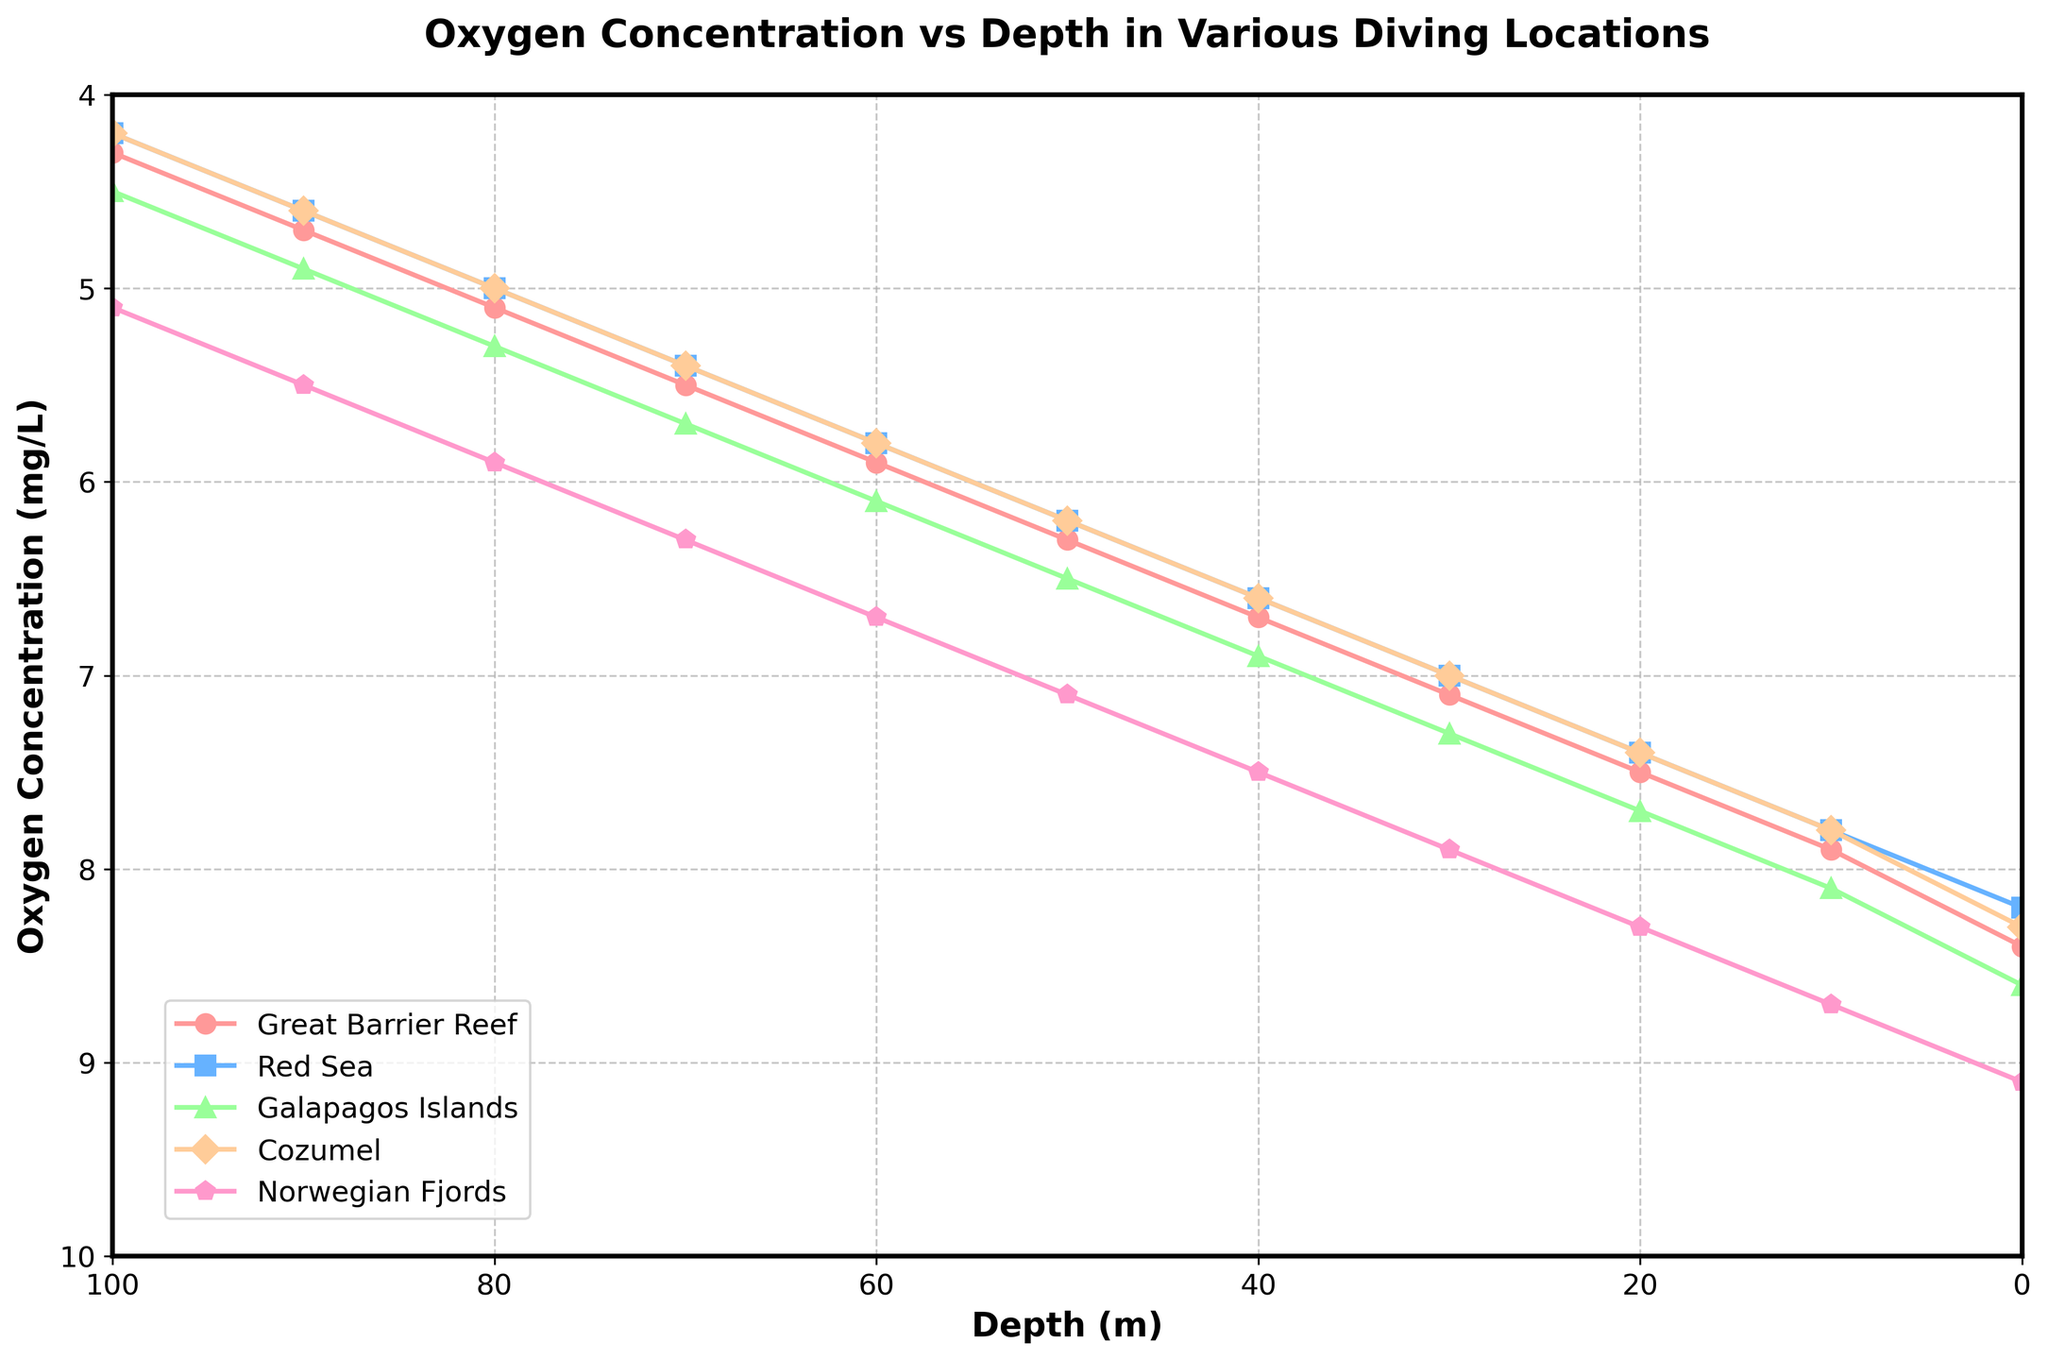Which location has the highest oxygen concentration at the surface (0 m)? Observe the y-axis values at 0 m depth for each location. The highest value is for the Norwegian Fjords.
Answer: Norwegian Fjords How does oxygen concentration in the Red Sea at 50 m depth compare to that in the Galapagos Islands at the same depth? Check the y-axis values at 50 m depth for both locations. The Red Sea has 6.2 mg/L and the Galapagos Islands have 6.5 mg/L.
Answer: Galapagos Islands is higher What is the average oxygen concentration at 30 m depth across all locations? Sum the oxygen concentrations at 30 m for all locations (7.1 + 7.0 + 7.3 + 7.0 + 7.9) and divide by the number of locations (5). Calculation: (7.1 + 7.0 + 7.3 + 7.0 + 7.9) / 5 = 36.3 / 5 = 7.26 mg/L.
Answer: 7.26 mg/L At what depth does the Great Barrier Reef's oxygen concentration first drop below 5 mg/L? Check the plot for the Great Barrier Reef line, finding where it first dips below 5 mg/L. The depth is at 80 m.
Answer: 80 m Which location consistently has the lowest oxygen concentration across all depths? Compare the lines for the lowest position at each depth increment. The Red Sea consistently appears lower than others.
Answer: Red Sea Which depth range experiences the steepest decline in oxygen concentration in Cozumel? Check the slope of the Cozumel line across different depth ranges. The steepest decline appears between 0 m and 10 m.
Answer: 0 m to 10 m What is the total decrease in oxygen concentration for the Norwegian Fjords from 0 m to 100 m? Subtract the oxygen concentration at 100 m from that at 0 m for the Norwegian Fjords. Calculation: 9.1 - 5.1 = 4 mg/L.
Answer: 4 mg/L Is there any depth where the oxygen concentration in the Galapagos Islands is equal to the Red Sea? Compare the oxygen concentration values for each depth between the Galapagos Islands and the Red Sea. They both have the same oxygen concentration of 5.8 mg/L at 60 m depth.
Answer: 60 m 